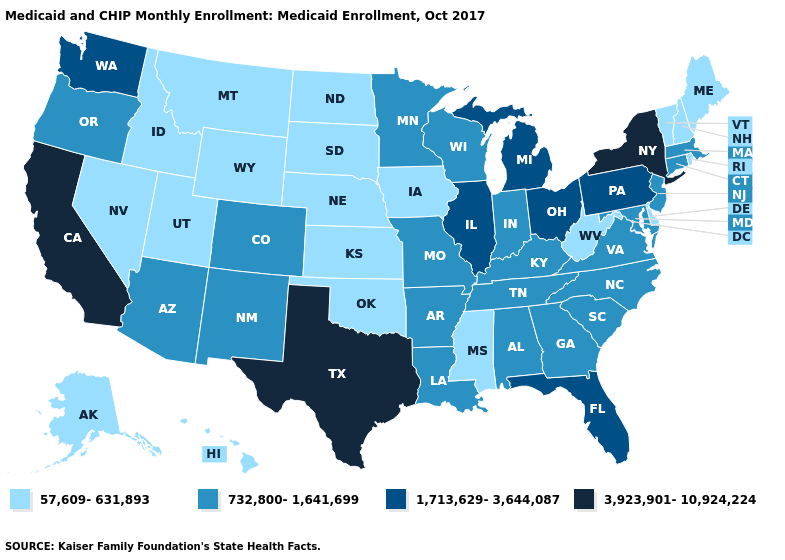Does Nevada have the same value as Connecticut?
Give a very brief answer. No. Among the states that border Tennessee , does Arkansas have the lowest value?
Be succinct. No. Does Oregon have a higher value than New Jersey?
Concise answer only. No. How many symbols are there in the legend?
Give a very brief answer. 4. What is the value of New York?
Concise answer only. 3,923,901-10,924,224. Name the states that have a value in the range 732,800-1,641,699?
Answer briefly. Alabama, Arizona, Arkansas, Colorado, Connecticut, Georgia, Indiana, Kentucky, Louisiana, Maryland, Massachusetts, Minnesota, Missouri, New Jersey, New Mexico, North Carolina, Oregon, South Carolina, Tennessee, Virginia, Wisconsin. Name the states that have a value in the range 1,713,629-3,644,087?
Answer briefly. Florida, Illinois, Michigan, Ohio, Pennsylvania, Washington. Name the states that have a value in the range 732,800-1,641,699?
Short answer required. Alabama, Arizona, Arkansas, Colorado, Connecticut, Georgia, Indiana, Kentucky, Louisiana, Maryland, Massachusetts, Minnesota, Missouri, New Jersey, New Mexico, North Carolina, Oregon, South Carolina, Tennessee, Virginia, Wisconsin. What is the highest value in the USA?
Quick response, please. 3,923,901-10,924,224. Name the states that have a value in the range 57,609-631,893?
Concise answer only. Alaska, Delaware, Hawaii, Idaho, Iowa, Kansas, Maine, Mississippi, Montana, Nebraska, Nevada, New Hampshire, North Dakota, Oklahoma, Rhode Island, South Dakota, Utah, Vermont, West Virginia, Wyoming. Does California have the highest value in the USA?
Be succinct. Yes. Among the states that border North Carolina , which have the lowest value?
Keep it brief. Georgia, South Carolina, Tennessee, Virginia. Does Nebraska have a lower value than Kentucky?
Write a very short answer. Yes. What is the value of California?
Write a very short answer. 3,923,901-10,924,224. Does California have the lowest value in the USA?
Short answer required. No. 